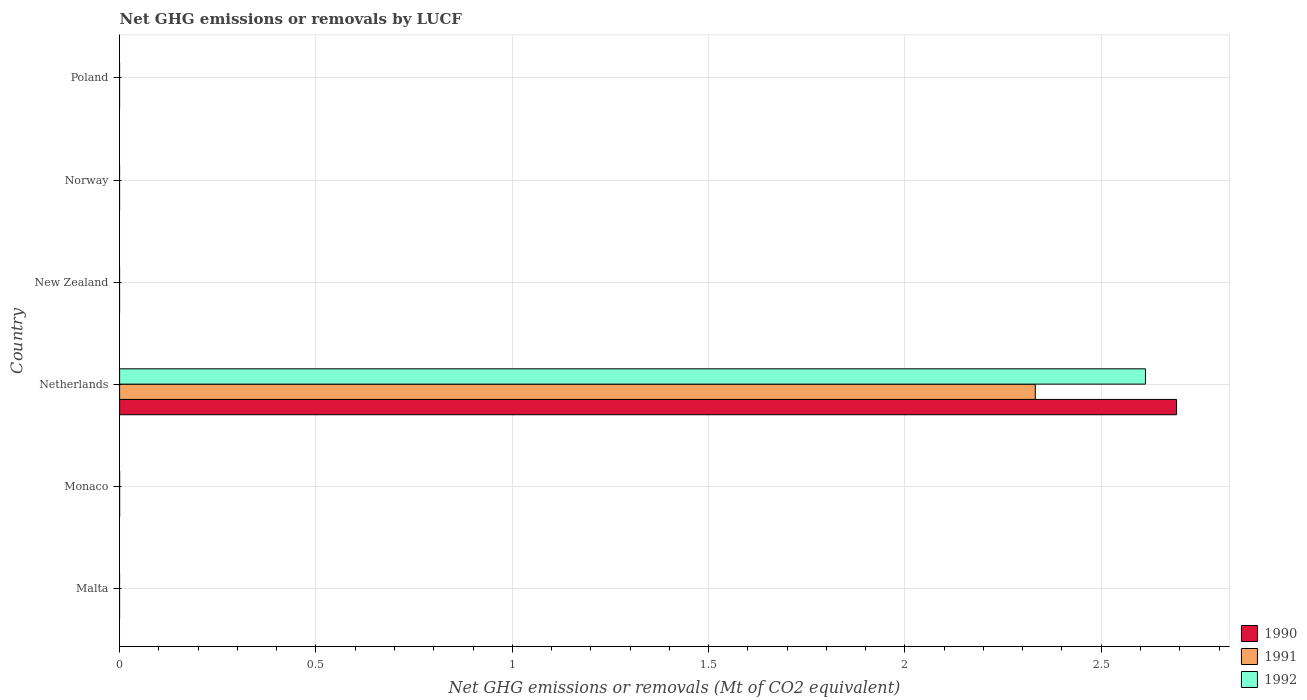Are the number of bars per tick equal to the number of legend labels?
Keep it short and to the point. No. How many bars are there on the 3rd tick from the top?
Offer a very short reply. 0. How many bars are there on the 3rd tick from the bottom?
Keep it short and to the point. 3. What is the label of the 5th group of bars from the top?
Provide a short and direct response. Monaco. In how many cases, is the number of bars for a given country not equal to the number of legend labels?
Provide a succinct answer. 5. What is the net GHG emissions or removals by LUCF in 1991 in Monaco?
Provide a succinct answer. 0. Across all countries, what is the maximum net GHG emissions or removals by LUCF in 1991?
Provide a succinct answer. 2.33. Across all countries, what is the minimum net GHG emissions or removals by LUCF in 1990?
Offer a terse response. 0. In which country was the net GHG emissions or removals by LUCF in 1990 maximum?
Offer a terse response. Netherlands. What is the total net GHG emissions or removals by LUCF in 1992 in the graph?
Offer a terse response. 2.61. What is the difference between the net GHG emissions or removals by LUCF in 1991 in New Zealand and the net GHG emissions or removals by LUCF in 1992 in Monaco?
Your response must be concise. 0. What is the average net GHG emissions or removals by LUCF in 1990 per country?
Give a very brief answer. 0.45. What is the difference between the net GHG emissions or removals by LUCF in 1991 and net GHG emissions or removals by LUCF in 1992 in Netherlands?
Ensure brevity in your answer.  -0.28. What is the difference between the highest and the lowest net GHG emissions or removals by LUCF in 1990?
Your answer should be compact. 2.69. How many bars are there?
Keep it short and to the point. 3. How many countries are there in the graph?
Your answer should be compact. 6. What is the difference between two consecutive major ticks on the X-axis?
Your response must be concise. 0.5. Does the graph contain grids?
Your response must be concise. Yes. How many legend labels are there?
Offer a terse response. 3. How are the legend labels stacked?
Your answer should be very brief. Vertical. What is the title of the graph?
Ensure brevity in your answer.  Net GHG emissions or removals by LUCF. Does "2005" appear as one of the legend labels in the graph?
Your answer should be compact. No. What is the label or title of the X-axis?
Give a very brief answer. Net GHG emissions or removals (Mt of CO2 equivalent). What is the label or title of the Y-axis?
Keep it short and to the point. Country. What is the Net GHG emissions or removals (Mt of CO2 equivalent) of 1990 in Monaco?
Offer a very short reply. 0. What is the Net GHG emissions or removals (Mt of CO2 equivalent) in 1992 in Monaco?
Your response must be concise. 0. What is the Net GHG emissions or removals (Mt of CO2 equivalent) in 1990 in Netherlands?
Provide a succinct answer. 2.69. What is the Net GHG emissions or removals (Mt of CO2 equivalent) of 1991 in Netherlands?
Give a very brief answer. 2.33. What is the Net GHG emissions or removals (Mt of CO2 equivalent) of 1992 in Netherlands?
Offer a very short reply. 2.61. What is the Net GHG emissions or removals (Mt of CO2 equivalent) of 1991 in New Zealand?
Provide a short and direct response. 0. What is the Net GHG emissions or removals (Mt of CO2 equivalent) in 1992 in New Zealand?
Keep it short and to the point. 0. What is the Net GHG emissions or removals (Mt of CO2 equivalent) in 1991 in Norway?
Keep it short and to the point. 0. What is the Net GHG emissions or removals (Mt of CO2 equivalent) in 1992 in Norway?
Make the answer very short. 0. What is the Net GHG emissions or removals (Mt of CO2 equivalent) of 1990 in Poland?
Provide a succinct answer. 0. Across all countries, what is the maximum Net GHG emissions or removals (Mt of CO2 equivalent) of 1990?
Make the answer very short. 2.69. Across all countries, what is the maximum Net GHG emissions or removals (Mt of CO2 equivalent) of 1991?
Your answer should be compact. 2.33. Across all countries, what is the maximum Net GHG emissions or removals (Mt of CO2 equivalent) of 1992?
Give a very brief answer. 2.61. Across all countries, what is the minimum Net GHG emissions or removals (Mt of CO2 equivalent) in 1990?
Offer a terse response. 0. Across all countries, what is the minimum Net GHG emissions or removals (Mt of CO2 equivalent) in 1991?
Give a very brief answer. 0. Across all countries, what is the minimum Net GHG emissions or removals (Mt of CO2 equivalent) in 1992?
Keep it short and to the point. 0. What is the total Net GHG emissions or removals (Mt of CO2 equivalent) of 1990 in the graph?
Provide a succinct answer. 2.69. What is the total Net GHG emissions or removals (Mt of CO2 equivalent) of 1991 in the graph?
Provide a succinct answer. 2.33. What is the total Net GHG emissions or removals (Mt of CO2 equivalent) in 1992 in the graph?
Your response must be concise. 2.61. What is the average Net GHG emissions or removals (Mt of CO2 equivalent) of 1990 per country?
Keep it short and to the point. 0.45. What is the average Net GHG emissions or removals (Mt of CO2 equivalent) of 1991 per country?
Make the answer very short. 0.39. What is the average Net GHG emissions or removals (Mt of CO2 equivalent) of 1992 per country?
Your response must be concise. 0.44. What is the difference between the Net GHG emissions or removals (Mt of CO2 equivalent) of 1990 and Net GHG emissions or removals (Mt of CO2 equivalent) of 1991 in Netherlands?
Your answer should be compact. 0.36. What is the difference between the Net GHG emissions or removals (Mt of CO2 equivalent) of 1990 and Net GHG emissions or removals (Mt of CO2 equivalent) of 1992 in Netherlands?
Make the answer very short. 0.08. What is the difference between the Net GHG emissions or removals (Mt of CO2 equivalent) in 1991 and Net GHG emissions or removals (Mt of CO2 equivalent) in 1992 in Netherlands?
Your answer should be compact. -0.28. What is the difference between the highest and the lowest Net GHG emissions or removals (Mt of CO2 equivalent) in 1990?
Your answer should be very brief. 2.69. What is the difference between the highest and the lowest Net GHG emissions or removals (Mt of CO2 equivalent) of 1991?
Provide a short and direct response. 2.33. What is the difference between the highest and the lowest Net GHG emissions or removals (Mt of CO2 equivalent) of 1992?
Your response must be concise. 2.61. 